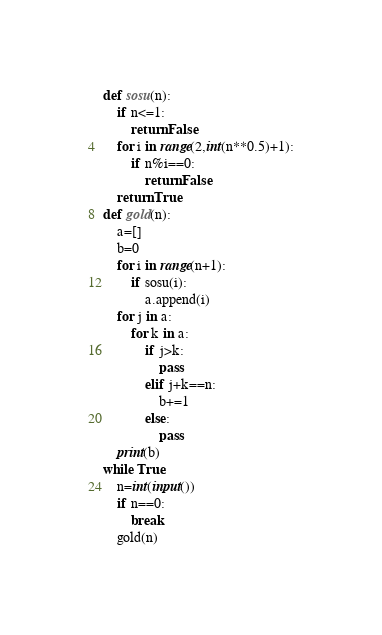<code> <loc_0><loc_0><loc_500><loc_500><_Python_>def sosu(n):
    if n<=1:
        return False
    for i in range(2,int(n**0.5)+1):
        if n%i==0:
            return False
    return True
def gold(n):
    a=[]
    b=0
    for i in range(n+1):
        if sosu(i):
            a.append(i)
    for j in a:
        for k in a:
            if j>k:
                pass
            elif j+k==n:
                b+=1
            else:
                pass
    print(b)
while True:
    n=int(input())
    if n==0:
        break
    gold(n)
</code> 